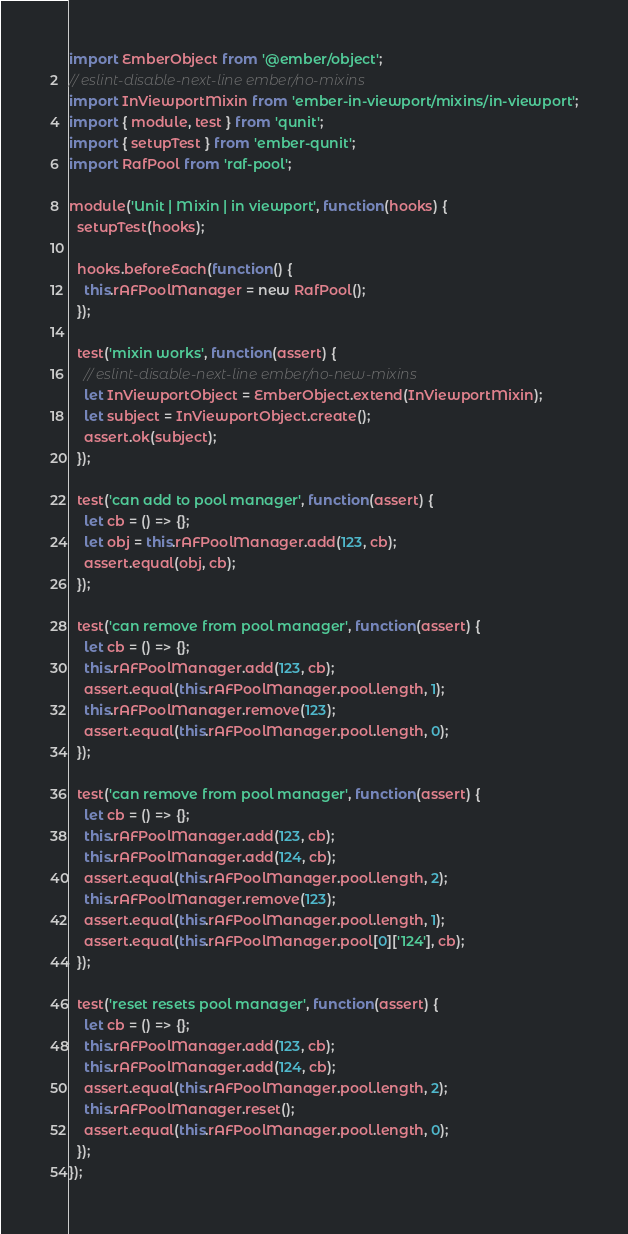<code> <loc_0><loc_0><loc_500><loc_500><_JavaScript_>import EmberObject from '@ember/object';
// eslint-disable-next-line ember/no-mixins
import InViewportMixin from 'ember-in-viewport/mixins/in-viewport';
import { module, test } from 'qunit';
import { setupTest } from 'ember-qunit';
import RafPool from 'raf-pool';

module('Unit | Mixin | in viewport', function(hooks) {
  setupTest(hooks);

  hooks.beforeEach(function() {
    this.rAFPoolManager = new RafPool();
  });

  test('mixin works', function(assert) {
    // eslint-disable-next-line ember/no-new-mixins
    let InViewportObject = EmberObject.extend(InViewportMixin);
    let subject = InViewportObject.create();
    assert.ok(subject);
  });

  test('can add to pool manager', function(assert) {
    let cb = () => {};
    let obj = this.rAFPoolManager.add(123, cb);
    assert.equal(obj, cb);
  });

  test('can remove from pool manager', function(assert) {
    let cb = () => {};
    this.rAFPoolManager.add(123, cb);
    assert.equal(this.rAFPoolManager.pool.length, 1);
    this.rAFPoolManager.remove(123);
    assert.equal(this.rAFPoolManager.pool.length, 0);
  });

  test('can remove from pool manager', function(assert) {
    let cb = () => {};
    this.rAFPoolManager.add(123, cb);
    this.rAFPoolManager.add(124, cb);
    assert.equal(this.rAFPoolManager.pool.length, 2);
    this.rAFPoolManager.remove(123);
    assert.equal(this.rAFPoolManager.pool.length, 1);
    assert.equal(this.rAFPoolManager.pool[0]['124'], cb);
  });

  test('reset resets pool manager', function(assert) {
    let cb = () => {};
    this.rAFPoolManager.add(123, cb);
    this.rAFPoolManager.add(124, cb);
    assert.equal(this.rAFPoolManager.pool.length, 2);
    this.rAFPoolManager.reset();
    assert.equal(this.rAFPoolManager.pool.length, 0);
  });
});
</code> 